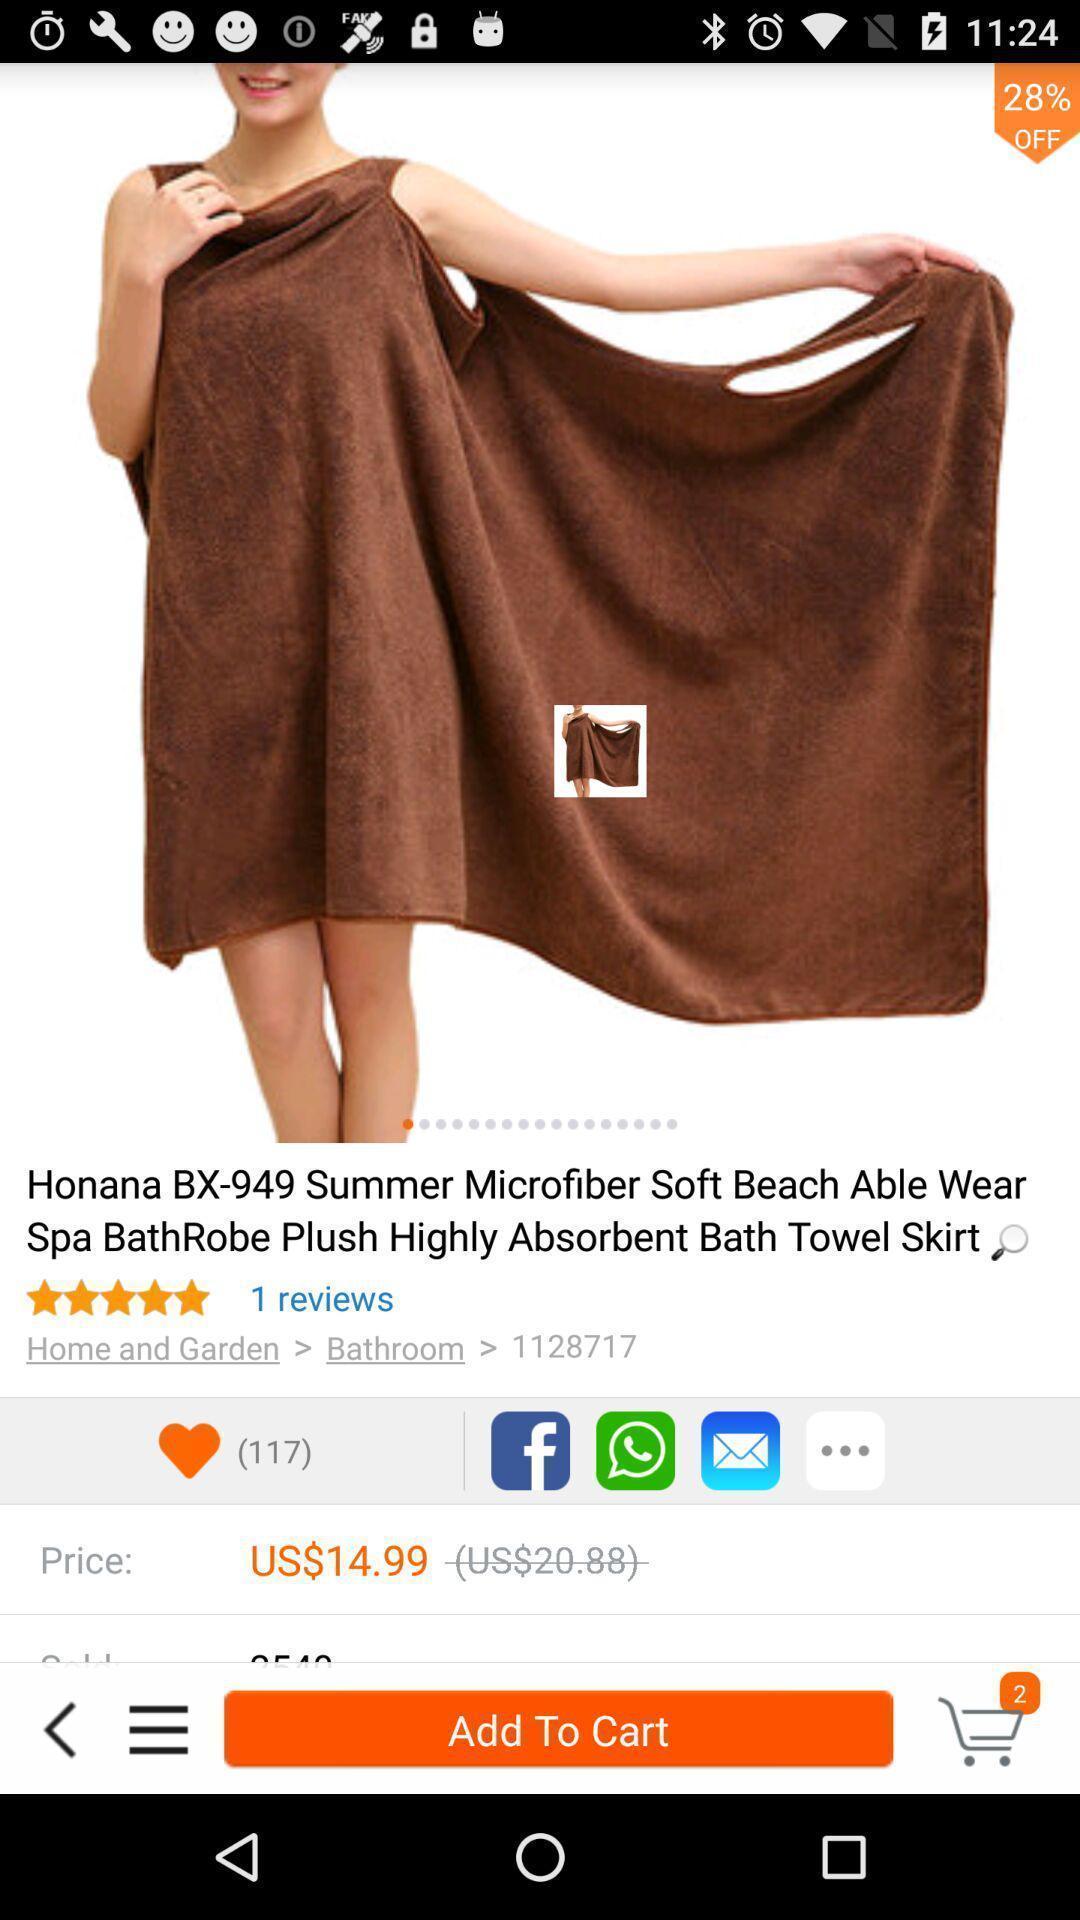Give me a summary of this screen capture. Screen is showing page of an shopping application. 